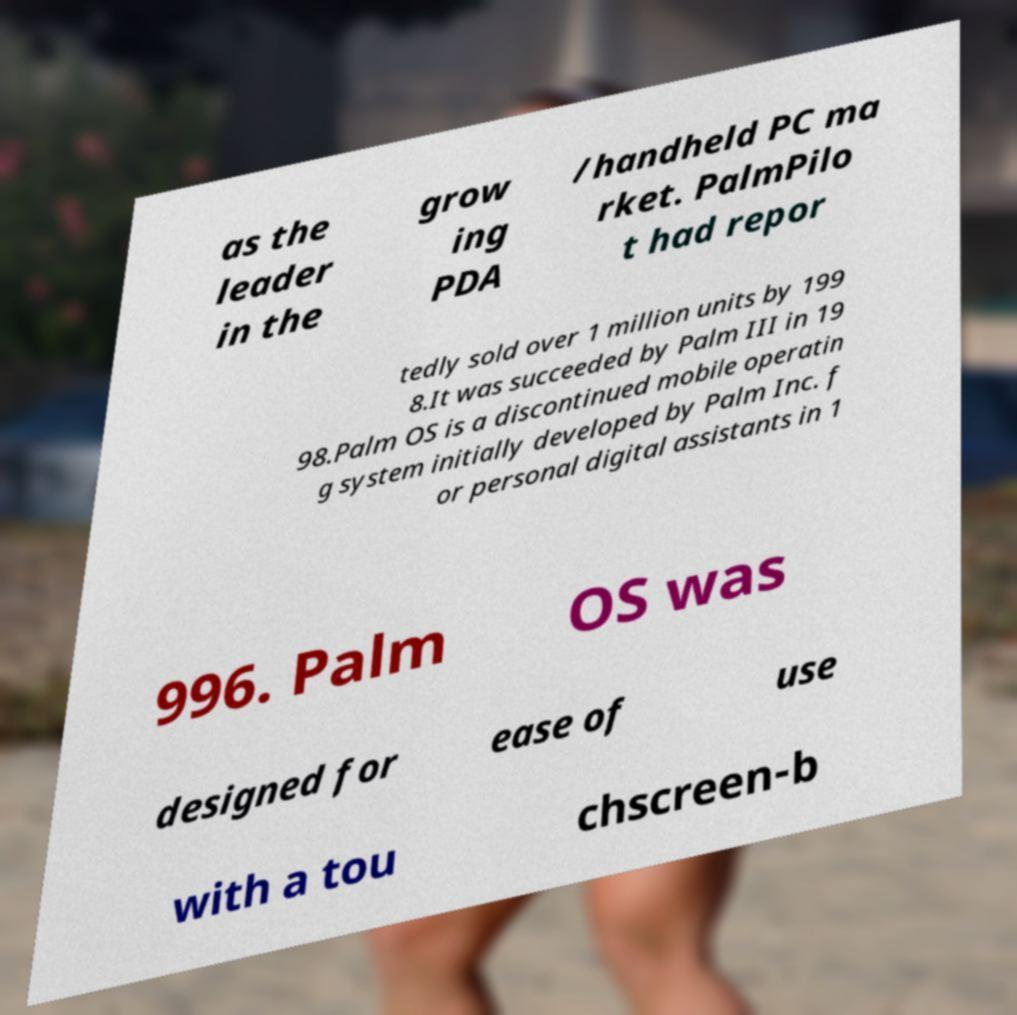Could you assist in decoding the text presented in this image and type it out clearly? as the leader in the grow ing PDA /handheld PC ma rket. PalmPilo t had repor tedly sold over 1 million units by 199 8.It was succeeded by Palm III in 19 98.Palm OS is a discontinued mobile operatin g system initially developed by Palm Inc. f or personal digital assistants in 1 996. Palm OS was designed for ease of use with a tou chscreen-b 